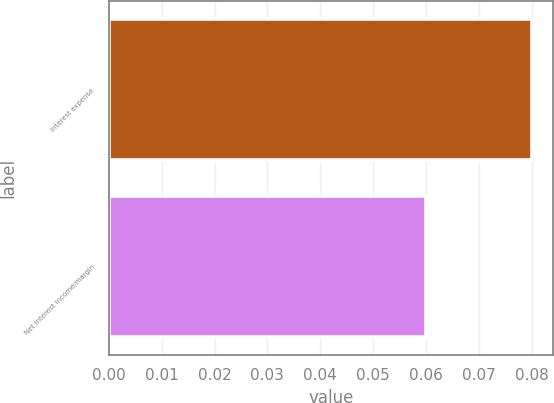Convert chart. <chart><loc_0><loc_0><loc_500><loc_500><bar_chart><fcel>Interest expense<fcel>Net interest income/margin<nl><fcel>0.08<fcel>0.06<nl></chart> 